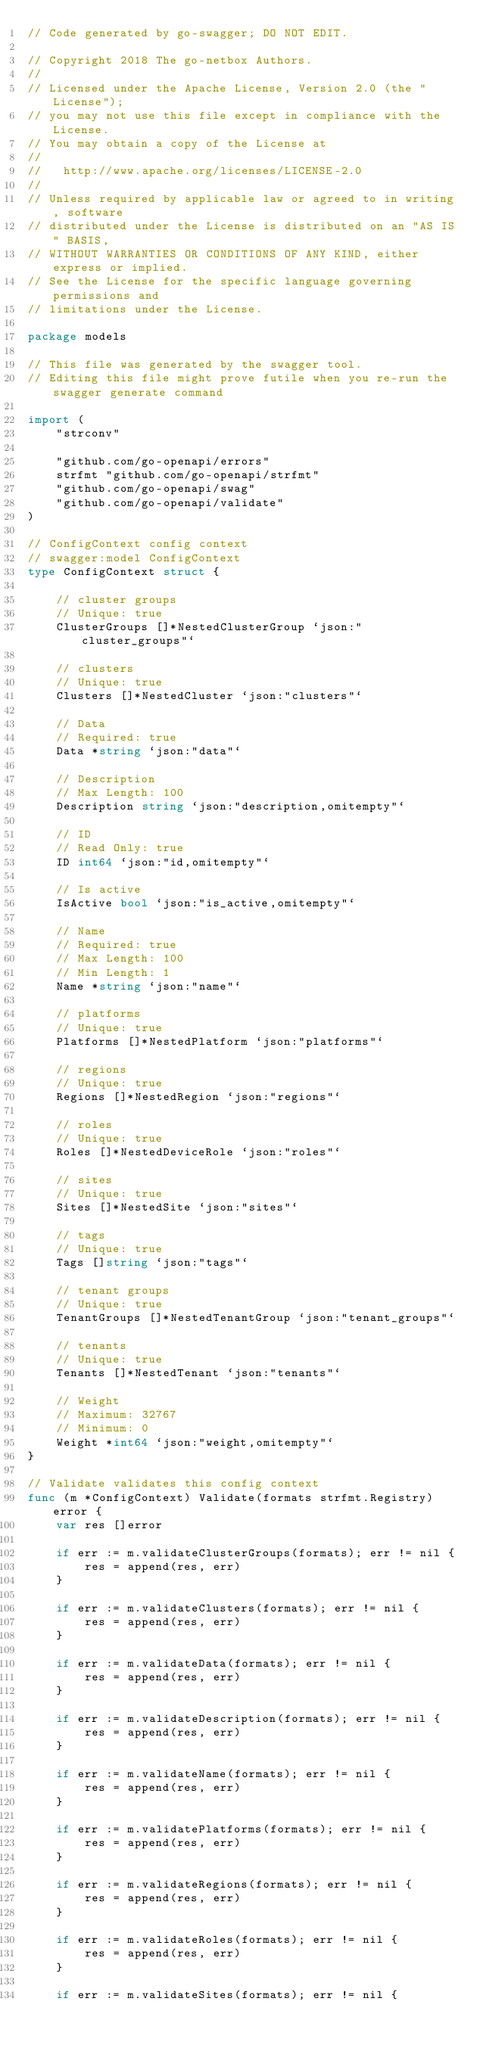<code> <loc_0><loc_0><loc_500><loc_500><_Go_>// Code generated by go-swagger; DO NOT EDIT.

// Copyright 2018 The go-netbox Authors.
//
// Licensed under the Apache License, Version 2.0 (the "License");
// you may not use this file except in compliance with the License.
// You may obtain a copy of the License at
//
//   http://www.apache.org/licenses/LICENSE-2.0
//
// Unless required by applicable law or agreed to in writing, software
// distributed under the License is distributed on an "AS IS" BASIS,
// WITHOUT WARRANTIES OR CONDITIONS OF ANY KIND, either express or implied.
// See the License for the specific language governing permissions and
// limitations under the License.

package models

// This file was generated by the swagger tool.
// Editing this file might prove futile when you re-run the swagger generate command

import (
	"strconv"

	"github.com/go-openapi/errors"
	strfmt "github.com/go-openapi/strfmt"
	"github.com/go-openapi/swag"
	"github.com/go-openapi/validate"
)

// ConfigContext config context
// swagger:model ConfigContext
type ConfigContext struct {

	// cluster groups
	// Unique: true
	ClusterGroups []*NestedClusterGroup `json:"cluster_groups"`

	// clusters
	// Unique: true
	Clusters []*NestedCluster `json:"clusters"`

	// Data
	// Required: true
	Data *string `json:"data"`

	// Description
	// Max Length: 100
	Description string `json:"description,omitempty"`

	// ID
	// Read Only: true
	ID int64 `json:"id,omitempty"`

	// Is active
	IsActive bool `json:"is_active,omitempty"`

	// Name
	// Required: true
	// Max Length: 100
	// Min Length: 1
	Name *string `json:"name"`

	// platforms
	// Unique: true
	Platforms []*NestedPlatform `json:"platforms"`

	// regions
	// Unique: true
	Regions []*NestedRegion `json:"regions"`

	// roles
	// Unique: true
	Roles []*NestedDeviceRole `json:"roles"`

	// sites
	// Unique: true
	Sites []*NestedSite `json:"sites"`

	// tags
	// Unique: true
	Tags []string `json:"tags"`

	// tenant groups
	// Unique: true
	TenantGroups []*NestedTenantGroup `json:"tenant_groups"`

	// tenants
	// Unique: true
	Tenants []*NestedTenant `json:"tenants"`

	// Weight
	// Maximum: 32767
	// Minimum: 0
	Weight *int64 `json:"weight,omitempty"`
}

// Validate validates this config context
func (m *ConfigContext) Validate(formats strfmt.Registry) error {
	var res []error

	if err := m.validateClusterGroups(formats); err != nil {
		res = append(res, err)
	}

	if err := m.validateClusters(formats); err != nil {
		res = append(res, err)
	}

	if err := m.validateData(formats); err != nil {
		res = append(res, err)
	}

	if err := m.validateDescription(formats); err != nil {
		res = append(res, err)
	}

	if err := m.validateName(formats); err != nil {
		res = append(res, err)
	}

	if err := m.validatePlatforms(formats); err != nil {
		res = append(res, err)
	}

	if err := m.validateRegions(formats); err != nil {
		res = append(res, err)
	}

	if err := m.validateRoles(formats); err != nil {
		res = append(res, err)
	}

	if err := m.validateSites(formats); err != nil {</code> 